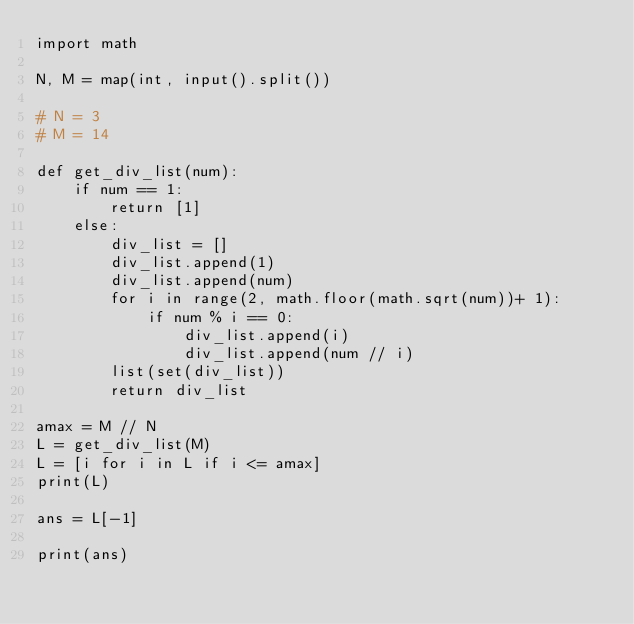Convert code to text. <code><loc_0><loc_0><loc_500><loc_500><_Python_>import math

N, M = map(int, input().split())

# N = 3
# M = 14

def get_div_list(num):
    if num == 1:
        return [1]
    else:
        div_list = []
        div_list.append(1)
        div_list.append(num)
        for i in range(2, math.floor(math.sqrt(num))+ 1):
            if num % i == 0:
                div_list.append(i)
                div_list.append(num // i)
        list(set(div_list))
        return div_list

amax = M // N
L = get_div_list(M)
L = [i for i in L if i <= amax]
print(L)

ans = L[-1]

print(ans)
</code> 